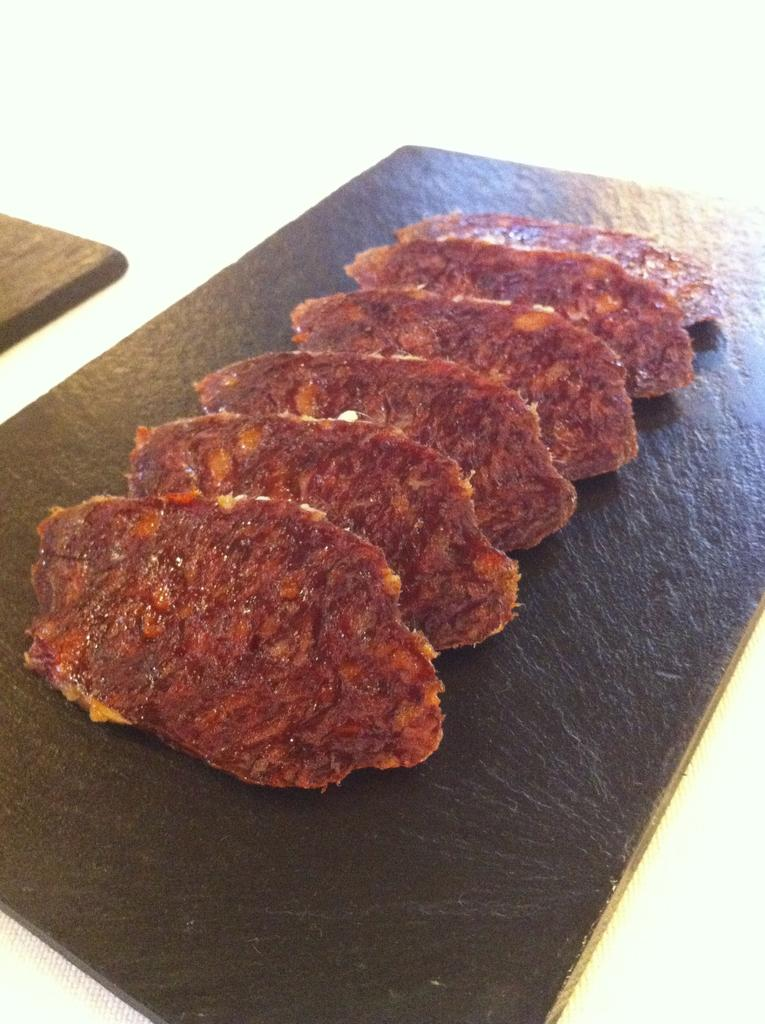What is the main subject of the image? The main subject of the image is food. What is the food placed on? The food is on a wooden object. What color is the background of the image? The background of the image is white in color. How many toes can be seen in the image? There are no toes visible in the image. 